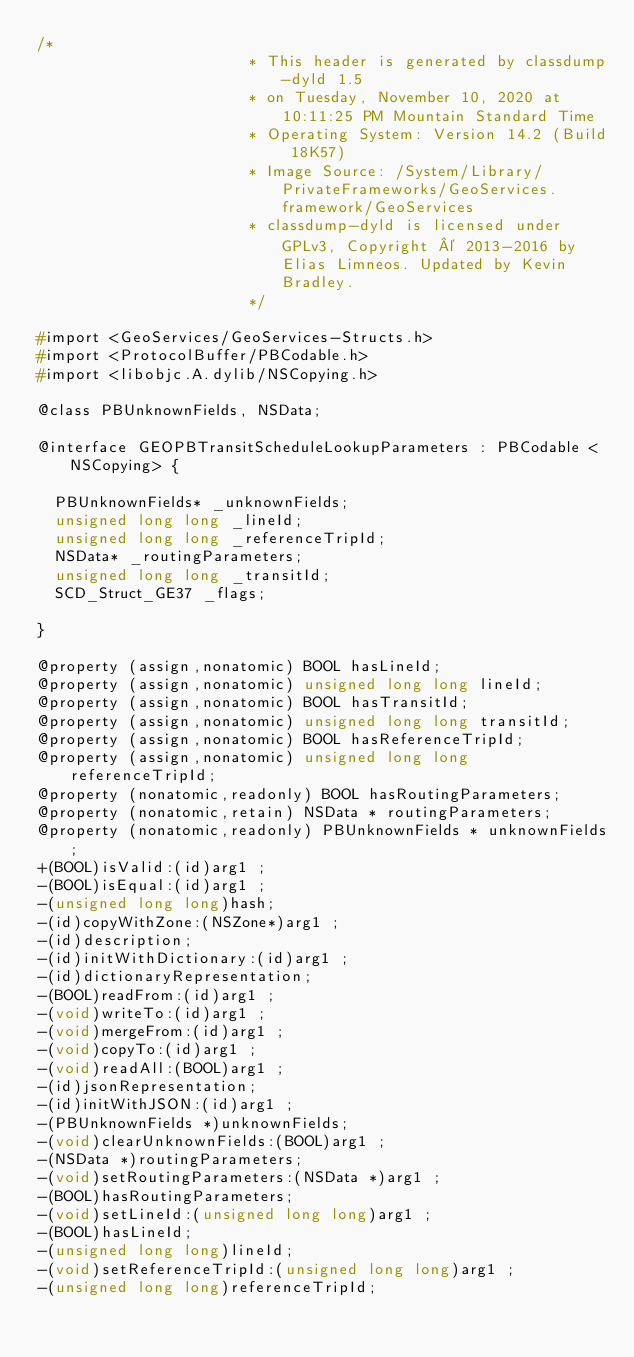Convert code to text. <code><loc_0><loc_0><loc_500><loc_500><_C_>/*
                       * This header is generated by classdump-dyld 1.5
                       * on Tuesday, November 10, 2020 at 10:11:25 PM Mountain Standard Time
                       * Operating System: Version 14.2 (Build 18K57)
                       * Image Source: /System/Library/PrivateFrameworks/GeoServices.framework/GeoServices
                       * classdump-dyld is licensed under GPLv3, Copyright © 2013-2016 by Elias Limneos. Updated by Kevin Bradley.
                       */

#import <GeoServices/GeoServices-Structs.h>
#import <ProtocolBuffer/PBCodable.h>
#import <libobjc.A.dylib/NSCopying.h>

@class PBUnknownFields, NSData;

@interface GEOPBTransitScheduleLookupParameters : PBCodable <NSCopying> {

	PBUnknownFields* _unknownFields;
	unsigned long long _lineId;
	unsigned long long _referenceTripId;
	NSData* _routingParameters;
	unsigned long long _transitId;
	SCD_Struct_GE37 _flags;

}

@property (assign,nonatomic) BOOL hasLineId; 
@property (assign,nonatomic) unsigned long long lineId; 
@property (assign,nonatomic) BOOL hasTransitId; 
@property (assign,nonatomic) unsigned long long transitId; 
@property (assign,nonatomic) BOOL hasReferenceTripId; 
@property (assign,nonatomic) unsigned long long referenceTripId; 
@property (nonatomic,readonly) BOOL hasRoutingParameters; 
@property (nonatomic,retain) NSData * routingParameters; 
@property (nonatomic,readonly) PBUnknownFields * unknownFields; 
+(BOOL)isValid:(id)arg1 ;
-(BOOL)isEqual:(id)arg1 ;
-(unsigned long long)hash;
-(id)copyWithZone:(NSZone*)arg1 ;
-(id)description;
-(id)initWithDictionary:(id)arg1 ;
-(id)dictionaryRepresentation;
-(BOOL)readFrom:(id)arg1 ;
-(void)writeTo:(id)arg1 ;
-(void)mergeFrom:(id)arg1 ;
-(void)copyTo:(id)arg1 ;
-(void)readAll:(BOOL)arg1 ;
-(id)jsonRepresentation;
-(id)initWithJSON:(id)arg1 ;
-(PBUnknownFields *)unknownFields;
-(void)clearUnknownFields:(BOOL)arg1 ;
-(NSData *)routingParameters;
-(void)setRoutingParameters:(NSData *)arg1 ;
-(BOOL)hasRoutingParameters;
-(void)setLineId:(unsigned long long)arg1 ;
-(BOOL)hasLineId;
-(unsigned long long)lineId;
-(void)setReferenceTripId:(unsigned long long)arg1 ;
-(unsigned long long)referenceTripId;</code> 